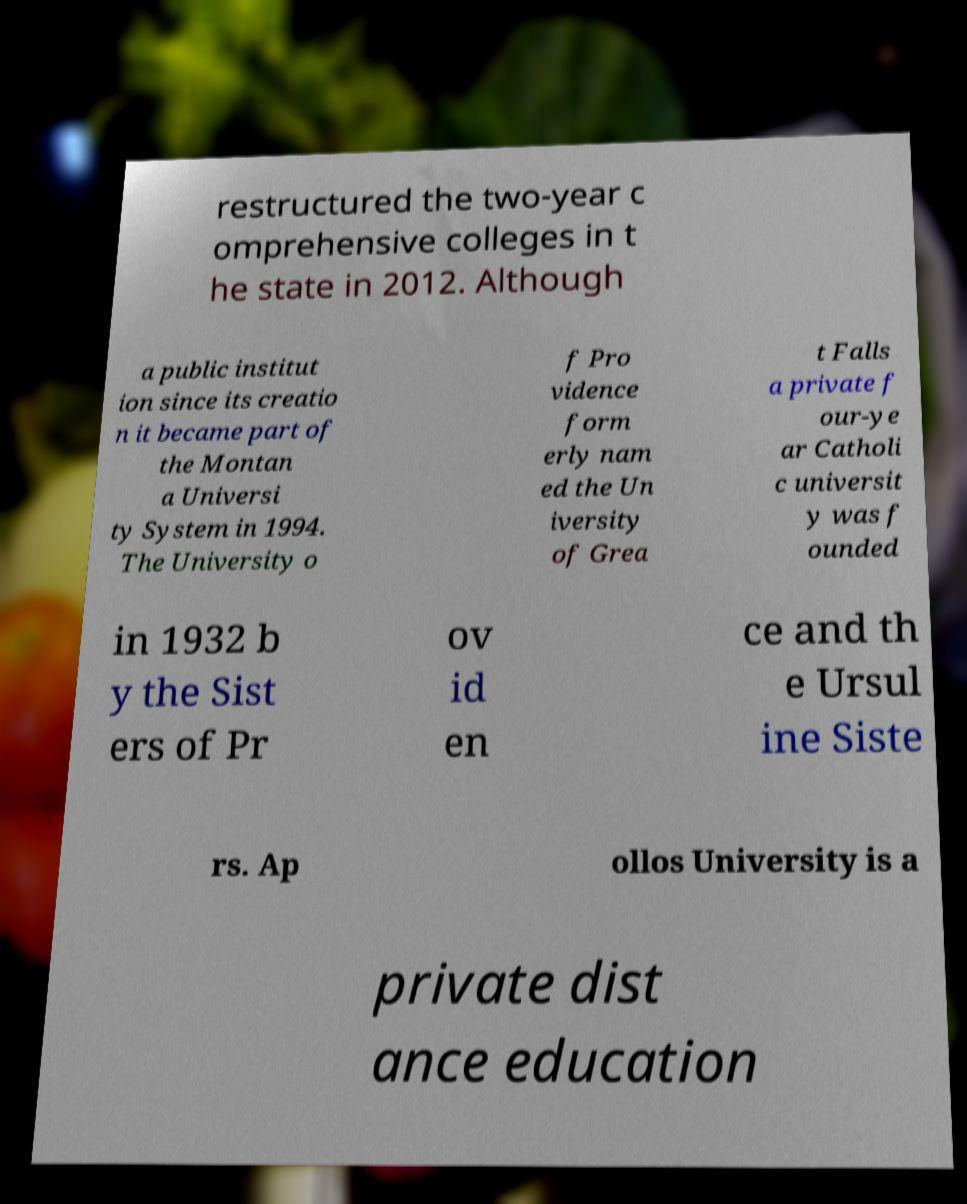Can you accurately transcribe the text from the provided image for me? restructured the two-year c omprehensive colleges in t he state in 2012. Although a public institut ion since its creatio n it became part of the Montan a Universi ty System in 1994. The University o f Pro vidence form erly nam ed the Un iversity of Grea t Falls a private f our-ye ar Catholi c universit y was f ounded in 1932 b y the Sist ers of Pr ov id en ce and th e Ursul ine Siste rs. Ap ollos University is a private dist ance education 